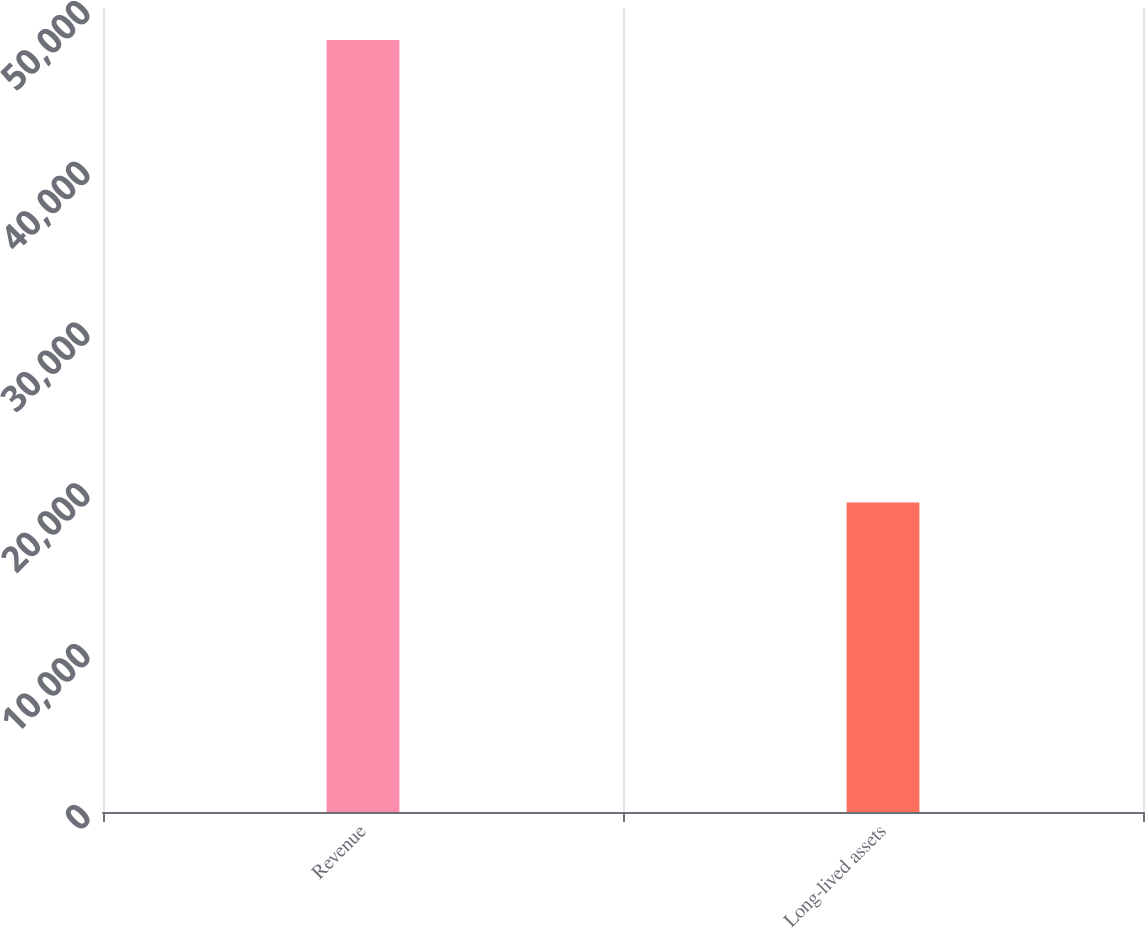Convert chart. <chart><loc_0><loc_0><loc_500><loc_500><bar_chart><fcel>Revenue<fcel>Long-lived assets<nl><fcel>48013<fcel>19253<nl></chart> 